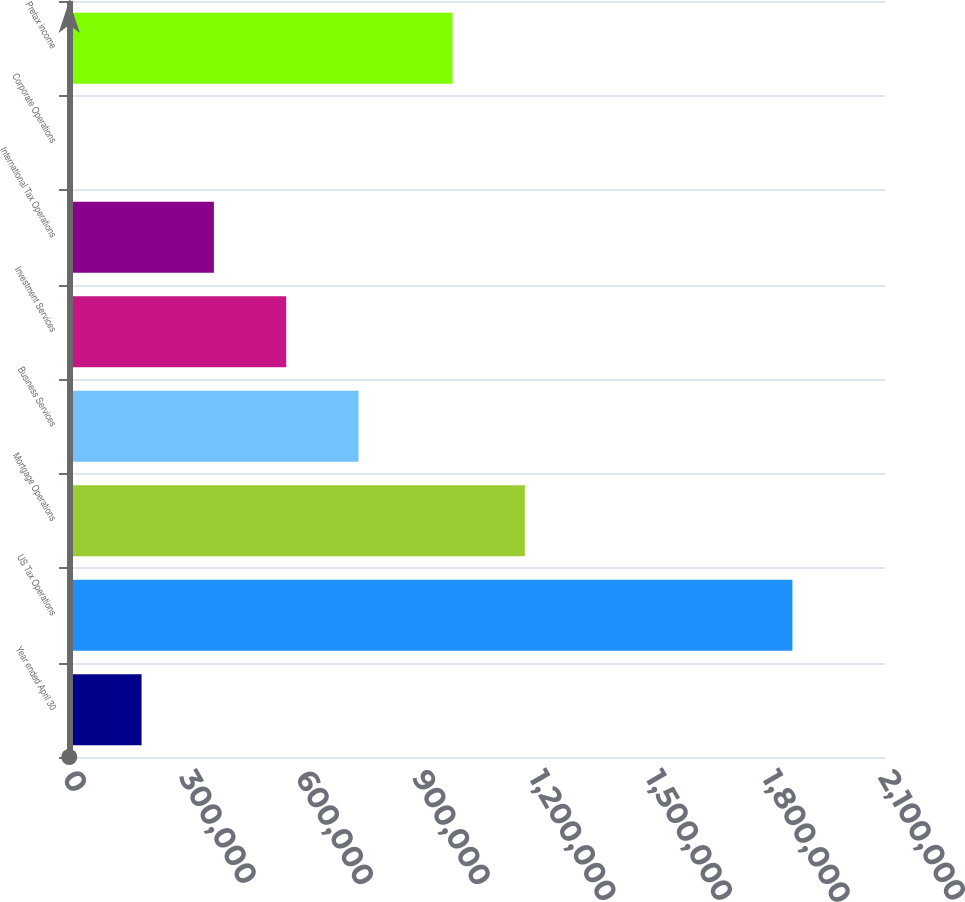Convert chart. <chart><loc_0><loc_0><loc_500><loc_500><bar_chart><fcel>Year ended April 30<fcel>US Tax Operations<fcel>Mortgage Operations<fcel>Business Services<fcel>Investment Services<fcel>International Tax Operations<fcel>Corporate Operations<fcel>Pretax income<nl><fcel>186754<fcel>1.86168e+06<fcel>1.17318e+06<fcel>745063<fcel>558960<fcel>372857<fcel>651<fcel>987077<nl></chart> 